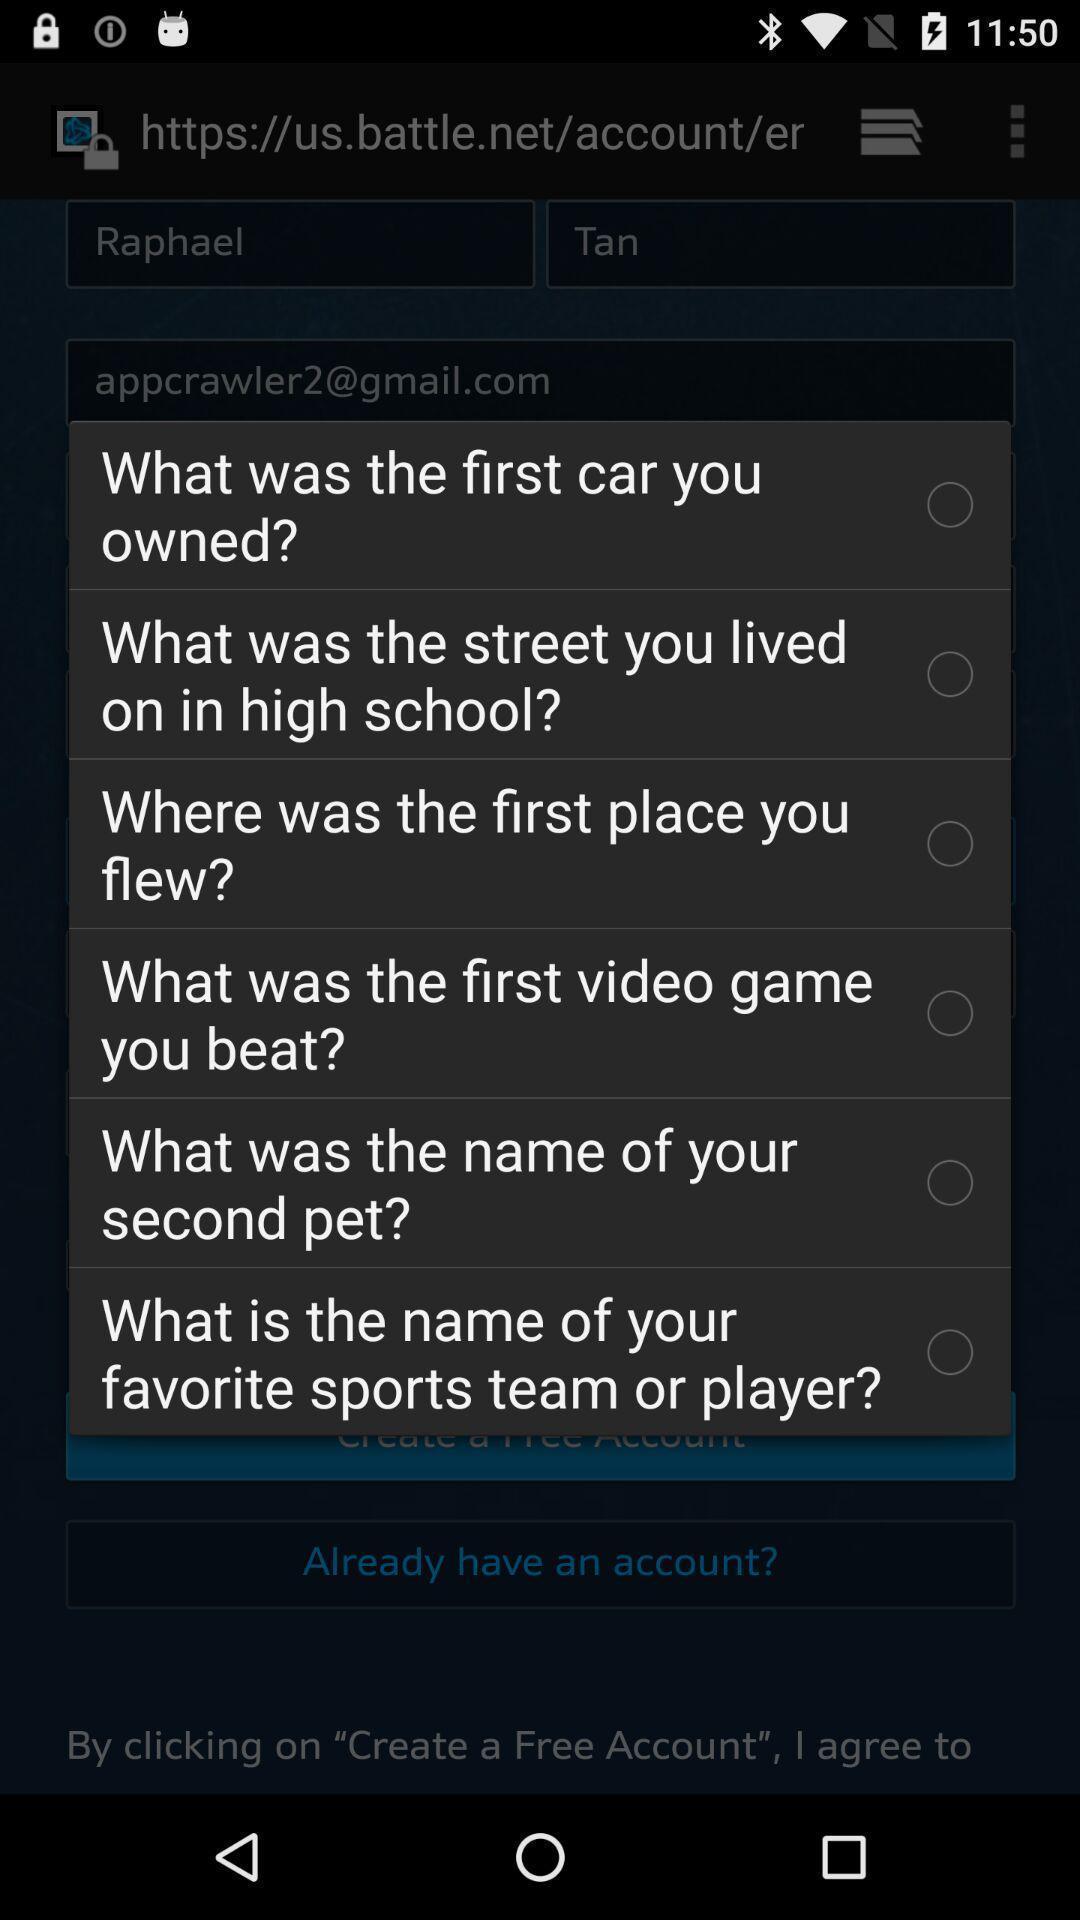Tell me about the visual elements in this screen capture. Popup page for choosing a inquiry question. 